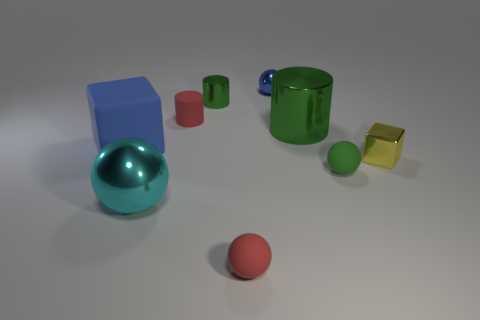What can you tell me about the lighting and shadows in the scene? The scene is illuminated by a soft, diffused light source coming from the upper right side, which is evident from the gentle shadows cast by the objects onto the white surface. The shadows are not very defined, suggesting a light source that is not very bright or is filtered through a diffuser to create a soft effect. This kind of lighting helps to bring out the colors of the objects without creating harsh contrasts. 